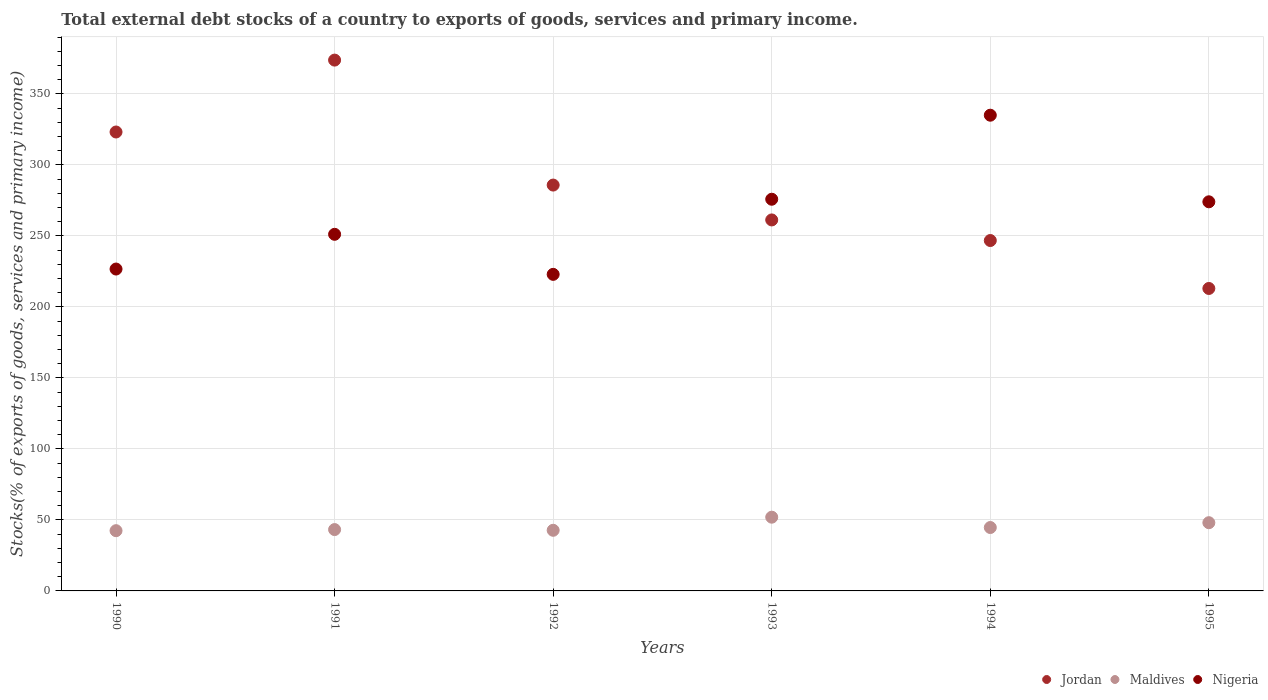How many different coloured dotlines are there?
Provide a short and direct response. 3. Is the number of dotlines equal to the number of legend labels?
Give a very brief answer. Yes. What is the total debt stocks in Nigeria in 1995?
Make the answer very short. 274.01. Across all years, what is the maximum total debt stocks in Jordan?
Give a very brief answer. 373.79. Across all years, what is the minimum total debt stocks in Nigeria?
Provide a succinct answer. 222.92. In which year was the total debt stocks in Maldives minimum?
Your answer should be very brief. 1990. What is the total total debt stocks in Nigeria in the graph?
Your answer should be compact. 1585.52. What is the difference between the total debt stocks in Nigeria in 1994 and that in 1995?
Provide a succinct answer. 60.98. What is the difference between the total debt stocks in Nigeria in 1994 and the total debt stocks in Jordan in 1990?
Give a very brief answer. 11.82. What is the average total debt stocks in Jordan per year?
Provide a succinct answer. 283.95. In the year 1991, what is the difference between the total debt stocks in Jordan and total debt stocks in Nigeria?
Provide a short and direct response. 122.67. In how many years, is the total debt stocks in Jordan greater than 120 %?
Provide a short and direct response. 6. What is the ratio of the total debt stocks in Jordan in 1990 to that in 1991?
Your answer should be compact. 0.86. Is the total debt stocks in Nigeria in 1990 less than that in 1992?
Provide a short and direct response. No. What is the difference between the highest and the second highest total debt stocks in Jordan?
Provide a succinct answer. 50.63. What is the difference between the highest and the lowest total debt stocks in Nigeria?
Ensure brevity in your answer.  112.07. Is it the case that in every year, the sum of the total debt stocks in Maldives and total debt stocks in Nigeria  is greater than the total debt stocks in Jordan?
Your answer should be compact. No. Is the total debt stocks in Maldives strictly greater than the total debt stocks in Jordan over the years?
Offer a very short reply. No. How many dotlines are there?
Offer a terse response. 3. How many years are there in the graph?
Give a very brief answer. 6. Are the values on the major ticks of Y-axis written in scientific E-notation?
Make the answer very short. No. Does the graph contain any zero values?
Your answer should be compact. No. Does the graph contain grids?
Provide a succinct answer. Yes. How many legend labels are there?
Offer a terse response. 3. What is the title of the graph?
Make the answer very short. Total external debt stocks of a country to exports of goods, services and primary income. Does "Tunisia" appear as one of the legend labels in the graph?
Your answer should be very brief. No. What is the label or title of the X-axis?
Provide a short and direct response. Years. What is the label or title of the Y-axis?
Your response must be concise. Stocks(% of exports of goods, services and primary income). What is the Stocks(% of exports of goods, services and primary income) of Jordan in 1990?
Ensure brevity in your answer.  323.17. What is the Stocks(% of exports of goods, services and primary income) in Maldives in 1990?
Ensure brevity in your answer.  42.42. What is the Stocks(% of exports of goods, services and primary income) of Nigeria in 1990?
Offer a terse response. 226.66. What is the Stocks(% of exports of goods, services and primary income) in Jordan in 1991?
Your answer should be compact. 373.79. What is the Stocks(% of exports of goods, services and primary income) in Maldives in 1991?
Offer a very short reply. 43.2. What is the Stocks(% of exports of goods, services and primary income) of Nigeria in 1991?
Make the answer very short. 251.12. What is the Stocks(% of exports of goods, services and primary income) of Jordan in 1992?
Your response must be concise. 285.8. What is the Stocks(% of exports of goods, services and primary income) of Maldives in 1992?
Provide a short and direct response. 42.7. What is the Stocks(% of exports of goods, services and primary income) of Nigeria in 1992?
Your answer should be very brief. 222.92. What is the Stocks(% of exports of goods, services and primary income) of Jordan in 1993?
Provide a succinct answer. 261.25. What is the Stocks(% of exports of goods, services and primary income) in Maldives in 1993?
Your answer should be compact. 51.92. What is the Stocks(% of exports of goods, services and primary income) in Nigeria in 1993?
Make the answer very short. 275.82. What is the Stocks(% of exports of goods, services and primary income) in Jordan in 1994?
Provide a succinct answer. 246.74. What is the Stocks(% of exports of goods, services and primary income) in Maldives in 1994?
Keep it short and to the point. 44.65. What is the Stocks(% of exports of goods, services and primary income) of Nigeria in 1994?
Your response must be concise. 334.99. What is the Stocks(% of exports of goods, services and primary income) in Jordan in 1995?
Keep it short and to the point. 212.98. What is the Stocks(% of exports of goods, services and primary income) of Maldives in 1995?
Your answer should be very brief. 48.04. What is the Stocks(% of exports of goods, services and primary income) in Nigeria in 1995?
Your response must be concise. 274.01. Across all years, what is the maximum Stocks(% of exports of goods, services and primary income) of Jordan?
Give a very brief answer. 373.79. Across all years, what is the maximum Stocks(% of exports of goods, services and primary income) of Maldives?
Give a very brief answer. 51.92. Across all years, what is the maximum Stocks(% of exports of goods, services and primary income) of Nigeria?
Your answer should be very brief. 334.99. Across all years, what is the minimum Stocks(% of exports of goods, services and primary income) of Jordan?
Your answer should be compact. 212.98. Across all years, what is the minimum Stocks(% of exports of goods, services and primary income) of Maldives?
Offer a very short reply. 42.42. Across all years, what is the minimum Stocks(% of exports of goods, services and primary income) in Nigeria?
Give a very brief answer. 222.92. What is the total Stocks(% of exports of goods, services and primary income) in Jordan in the graph?
Provide a succinct answer. 1703.72. What is the total Stocks(% of exports of goods, services and primary income) of Maldives in the graph?
Keep it short and to the point. 272.93. What is the total Stocks(% of exports of goods, services and primary income) of Nigeria in the graph?
Provide a succinct answer. 1585.52. What is the difference between the Stocks(% of exports of goods, services and primary income) in Jordan in 1990 and that in 1991?
Offer a very short reply. -50.63. What is the difference between the Stocks(% of exports of goods, services and primary income) of Maldives in 1990 and that in 1991?
Provide a short and direct response. -0.78. What is the difference between the Stocks(% of exports of goods, services and primary income) of Nigeria in 1990 and that in 1991?
Your answer should be compact. -24.46. What is the difference between the Stocks(% of exports of goods, services and primary income) of Jordan in 1990 and that in 1992?
Offer a very short reply. 37.37. What is the difference between the Stocks(% of exports of goods, services and primary income) in Maldives in 1990 and that in 1992?
Give a very brief answer. -0.28. What is the difference between the Stocks(% of exports of goods, services and primary income) in Nigeria in 1990 and that in 1992?
Make the answer very short. 3.74. What is the difference between the Stocks(% of exports of goods, services and primary income) in Jordan in 1990 and that in 1993?
Your answer should be very brief. 61.92. What is the difference between the Stocks(% of exports of goods, services and primary income) of Maldives in 1990 and that in 1993?
Give a very brief answer. -9.5. What is the difference between the Stocks(% of exports of goods, services and primary income) of Nigeria in 1990 and that in 1993?
Offer a terse response. -49.16. What is the difference between the Stocks(% of exports of goods, services and primary income) of Jordan in 1990 and that in 1994?
Make the answer very short. 76.42. What is the difference between the Stocks(% of exports of goods, services and primary income) of Maldives in 1990 and that in 1994?
Offer a terse response. -2.23. What is the difference between the Stocks(% of exports of goods, services and primary income) of Nigeria in 1990 and that in 1994?
Make the answer very short. -108.33. What is the difference between the Stocks(% of exports of goods, services and primary income) in Jordan in 1990 and that in 1995?
Your response must be concise. 110.18. What is the difference between the Stocks(% of exports of goods, services and primary income) of Maldives in 1990 and that in 1995?
Your response must be concise. -5.62. What is the difference between the Stocks(% of exports of goods, services and primary income) of Nigeria in 1990 and that in 1995?
Provide a short and direct response. -47.35. What is the difference between the Stocks(% of exports of goods, services and primary income) in Jordan in 1991 and that in 1992?
Offer a very short reply. 88. What is the difference between the Stocks(% of exports of goods, services and primary income) in Maldives in 1991 and that in 1992?
Offer a very short reply. 0.5. What is the difference between the Stocks(% of exports of goods, services and primary income) of Nigeria in 1991 and that in 1992?
Provide a short and direct response. 28.2. What is the difference between the Stocks(% of exports of goods, services and primary income) in Jordan in 1991 and that in 1993?
Your answer should be compact. 112.55. What is the difference between the Stocks(% of exports of goods, services and primary income) in Maldives in 1991 and that in 1993?
Your answer should be very brief. -8.73. What is the difference between the Stocks(% of exports of goods, services and primary income) of Nigeria in 1991 and that in 1993?
Provide a succinct answer. -24.7. What is the difference between the Stocks(% of exports of goods, services and primary income) of Jordan in 1991 and that in 1994?
Give a very brief answer. 127.05. What is the difference between the Stocks(% of exports of goods, services and primary income) of Maldives in 1991 and that in 1994?
Give a very brief answer. -1.45. What is the difference between the Stocks(% of exports of goods, services and primary income) of Nigeria in 1991 and that in 1994?
Ensure brevity in your answer.  -83.87. What is the difference between the Stocks(% of exports of goods, services and primary income) of Jordan in 1991 and that in 1995?
Ensure brevity in your answer.  160.81. What is the difference between the Stocks(% of exports of goods, services and primary income) of Maldives in 1991 and that in 1995?
Make the answer very short. -4.84. What is the difference between the Stocks(% of exports of goods, services and primary income) in Nigeria in 1991 and that in 1995?
Offer a terse response. -22.89. What is the difference between the Stocks(% of exports of goods, services and primary income) in Jordan in 1992 and that in 1993?
Offer a terse response. 24.55. What is the difference between the Stocks(% of exports of goods, services and primary income) in Maldives in 1992 and that in 1993?
Keep it short and to the point. -9.23. What is the difference between the Stocks(% of exports of goods, services and primary income) in Nigeria in 1992 and that in 1993?
Provide a short and direct response. -52.89. What is the difference between the Stocks(% of exports of goods, services and primary income) in Jordan in 1992 and that in 1994?
Offer a very short reply. 39.05. What is the difference between the Stocks(% of exports of goods, services and primary income) of Maldives in 1992 and that in 1994?
Keep it short and to the point. -1.95. What is the difference between the Stocks(% of exports of goods, services and primary income) of Nigeria in 1992 and that in 1994?
Keep it short and to the point. -112.07. What is the difference between the Stocks(% of exports of goods, services and primary income) of Jordan in 1992 and that in 1995?
Give a very brief answer. 72.81. What is the difference between the Stocks(% of exports of goods, services and primary income) in Maldives in 1992 and that in 1995?
Make the answer very short. -5.35. What is the difference between the Stocks(% of exports of goods, services and primary income) of Nigeria in 1992 and that in 1995?
Keep it short and to the point. -51.09. What is the difference between the Stocks(% of exports of goods, services and primary income) of Jordan in 1993 and that in 1994?
Give a very brief answer. 14.51. What is the difference between the Stocks(% of exports of goods, services and primary income) of Maldives in 1993 and that in 1994?
Your answer should be very brief. 7.27. What is the difference between the Stocks(% of exports of goods, services and primary income) in Nigeria in 1993 and that in 1994?
Your answer should be very brief. -59.18. What is the difference between the Stocks(% of exports of goods, services and primary income) of Jordan in 1993 and that in 1995?
Offer a terse response. 48.27. What is the difference between the Stocks(% of exports of goods, services and primary income) in Maldives in 1993 and that in 1995?
Your response must be concise. 3.88. What is the difference between the Stocks(% of exports of goods, services and primary income) in Nigeria in 1993 and that in 1995?
Your answer should be compact. 1.8. What is the difference between the Stocks(% of exports of goods, services and primary income) of Jordan in 1994 and that in 1995?
Give a very brief answer. 33.76. What is the difference between the Stocks(% of exports of goods, services and primary income) in Maldives in 1994 and that in 1995?
Your answer should be very brief. -3.39. What is the difference between the Stocks(% of exports of goods, services and primary income) in Nigeria in 1994 and that in 1995?
Offer a terse response. 60.98. What is the difference between the Stocks(% of exports of goods, services and primary income) of Jordan in 1990 and the Stocks(% of exports of goods, services and primary income) of Maldives in 1991?
Keep it short and to the point. 279.97. What is the difference between the Stocks(% of exports of goods, services and primary income) of Jordan in 1990 and the Stocks(% of exports of goods, services and primary income) of Nigeria in 1991?
Keep it short and to the point. 72.05. What is the difference between the Stocks(% of exports of goods, services and primary income) of Maldives in 1990 and the Stocks(% of exports of goods, services and primary income) of Nigeria in 1991?
Your answer should be very brief. -208.7. What is the difference between the Stocks(% of exports of goods, services and primary income) in Jordan in 1990 and the Stocks(% of exports of goods, services and primary income) in Maldives in 1992?
Offer a very short reply. 280.47. What is the difference between the Stocks(% of exports of goods, services and primary income) of Jordan in 1990 and the Stocks(% of exports of goods, services and primary income) of Nigeria in 1992?
Provide a short and direct response. 100.24. What is the difference between the Stocks(% of exports of goods, services and primary income) of Maldives in 1990 and the Stocks(% of exports of goods, services and primary income) of Nigeria in 1992?
Make the answer very short. -180.5. What is the difference between the Stocks(% of exports of goods, services and primary income) of Jordan in 1990 and the Stocks(% of exports of goods, services and primary income) of Maldives in 1993?
Your response must be concise. 271.24. What is the difference between the Stocks(% of exports of goods, services and primary income) of Jordan in 1990 and the Stocks(% of exports of goods, services and primary income) of Nigeria in 1993?
Make the answer very short. 47.35. What is the difference between the Stocks(% of exports of goods, services and primary income) in Maldives in 1990 and the Stocks(% of exports of goods, services and primary income) in Nigeria in 1993?
Provide a succinct answer. -233.4. What is the difference between the Stocks(% of exports of goods, services and primary income) in Jordan in 1990 and the Stocks(% of exports of goods, services and primary income) in Maldives in 1994?
Your answer should be very brief. 278.52. What is the difference between the Stocks(% of exports of goods, services and primary income) of Jordan in 1990 and the Stocks(% of exports of goods, services and primary income) of Nigeria in 1994?
Ensure brevity in your answer.  -11.82. What is the difference between the Stocks(% of exports of goods, services and primary income) of Maldives in 1990 and the Stocks(% of exports of goods, services and primary income) of Nigeria in 1994?
Provide a short and direct response. -292.57. What is the difference between the Stocks(% of exports of goods, services and primary income) of Jordan in 1990 and the Stocks(% of exports of goods, services and primary income) of Maldives in 1995?
Provide a succinct answer. 275.12. What is the difference between the Stocks(% of exports of goods, services and primary income) in Jordan in 1990 and the Stocks(% of exports of goods, services and primary income) in Nigeria in 1995?
Offer a terse response. 49.15. What is the difference between the Stocks(% of exports of goods, services and primary income) in Maldives in 1990 and the Stocks(% of exports of goods, services and primary income) in Nigeria in 1995?
Your answer should be very brief. -231.59. What is the difference between the Stocks(% of exports of goods, services and primary income) of Jordan in 1991 and the Stocks(% of exports of goods, services and primary income) of Maldives in 1992?
Provide a succinct answer. 331.1. What is the difference between the Stocks(% of exports of goods, services and primary income) in Jordan in 1991 and the Stocks(% of exports of goods, services and primary income) in Nigeria in 1992?
Provide a short and direct response. 150.87. What is the difference between the Stocks(% of exports of goods, services and primary income) in Maldives in 1991 and the Stocks(% of exports of goods, services and primary income) in Nigeria in 1992?
Your answer should be very brief. -179.72. What is the difference between the Stocks(% of exports of goods, services and primary income) in Jordan in 1991 and the Stocks(% of exports of goods, services and primary income) in Maldives in 1993?
Keep it short and to the point. 321.87. What is the difference between the Stocks(% of exports of goods, services and primary income) in Jordan in 1991 and the Stocks(% of exports of goods, services and primary income) in Nigeria in 1993?
Offer a terse response. 97.98. What is the difference between the Stocks(% of exports of goods, services and primary income) of Maldives in 1991 and the Stocks(% of exports of goods, services and primary income) of Nigeria in 1993?
Provide a short and direct response. -232.62. What is the difference between the Stocks(% of exports of goods, services and primary income) of Jordan in 1991 and the Stocks(% of exports of goods, services and primary income) of Maldives in 1994?
Keep it short and to the point. 329.14. What is the difference between the Stocks(% of exports of goods, services and primary income) in Jordan in 1991 and the Stocks(% of exports of goods, services and primary income) in Nigeria in 1994?
Provide a short and direct response. 38.8. What is the difference between the Stocks(% of exports of goods, services and primary income) of Maldives in 1991 and the Stocks(% of exports of goods, services and primary income) of Nigeria in 1994?
Make the answer very short. -291.79. What is the difference between the Stocks(% of exports of goods, services and primary income) in Jordan in 1991 and the Stocks(% of exports of goods, services and primary income) in Maldives in 1995?
Your answer should be very brief. 325.75. What is the difference between the Stocks(% of exports of goods, services and primary income) of Jordan in 1991 and the Stocks(% of exports of goods, services and primary income) of Nigeria in 1995?
Provide a succinct answer. 99.78. What is the difference between the Stocks(% of exports of goods, services and primary income) of Maldives in 1991 and the Stocks(% of exports of goods, services and primary income) of Nigeria in 1995?
Ensure brevity in your answer.  -230.81. What is the difference between the Stocks(% of exports of goods, services and primary income) in Jordan in 1992 and the Stocks(% of exports of goods, services and primary income) in Maldives in 1993?
Provide a short and direct response. 233.87. What is the difference between the Stocks(% of exports of goods, services and primary income) in Jordan in 1992 and the Stocks(% of exports of goods, services and primary income) in Nigeria in 1993?
Your answer should be compact. 9.98. What is the difference between the Stocks(% of exports of goods, services and primary income) of Maldives in 1992 and the Stocks(% of exports of goods, services and primary income) of Nigeria in 1993?
Your answer should be very brief. -233.12. What is the difference between the Stocks(% of exports of goods, services and primary income) in Jordan in 1992 and the Stocks(% of exports of goods, services and primary income) in Maldives in 1994?
Provide a succinct answer. 241.15. What is the difference between the Stocks(% of exports of goods, services and primary income) of Jordan in 1992 and the Stocks(% of exports of goods, services and primary income) of Nigeria in 1994?
Offer a very short reply. -49.19. What is the difference between the Stocks(% of exports of goods, services and primary income) of Maldives in 1992 and the Stocks(% of exports of goods, services and primary income) of Nigeria in 1994?
Give a very brief answer. -292.29. What is the difference between the Stocks(% of exports of goods, services and primary income) in Jordan in 1992 and the Stocks(% of exports of goods, services and primary income) in Maldives in 1995?
Make the answer very short. 237.75. What is the difference between the Stocks(% of exports of goods, services and primary income) of Jordan in 1992 and the Stocks(% of exports of goods, services and primary income) of Nigeria in 1995?
Provide a short and direct response. 11.79. What is the difference between the Stocks(% of exports of goods, services and primary income) in Maldives in 1992 and the Stocks(% of exports of goods, services and primary income) in Nigeria in 1995?
Offer a very short reply. -231.31. What is the difference between the Stocks(% of exports of goods, services and primary income) in Jordan in 1993 and the Stocks(% of exports of goods, services and primary income) in Maldives in 1994?
Give a very brief answer. 216.6. What is the difference between the Stocks(% of exports of goods, services and primary income) in Jordan in 1993 and the Stocks(% of exports of goods, services and primary income) in Nigeria in 1994?
Offer a very short reply. -73.74. What is the difference between the Stocks(% of exports of goods, services and primary income) of Maldives in 1993 and the Stocks(% of exports of goods, services and primary income) of Nigeria in 1994?
Provide a short and direct response. -283.07. What is the difference between the Stocks(% of exports of goods, services and primary income) in Jordan in 1993 and the Stocks(% of exports of goods, services and primary income) in Maldives in 1995?
Make the answer very short. 213.2. What is the difference between the Stocks(% of exports of goods, services and primary income) in Jordan in 1993 and the Stocks(% of exports of goods, services and primary income) in Nigeria in 1995?
Provide a succinct answer. -12.76. What is the difference between the Stocks(% of exports of goods, services and primary income) in Maldives in 1993 and the Stocks(% of exports of goods, services and primary income) in Nigeria in 1995?
Ensure brevity in your answer.  -222.09. What is the difference between the Stocks(% of exports of goods, services and primary income) of Jordan in 1994 and the Stocks(% of exports of goods, services and primary income) of Maldives in 1995?
Provide a short and direct response. 198.7. What is the difference between the Stocks(% of exports of goods, services and primary income) of Jordan in 1994 and the Stocks(% of exports of goods, services and primary income) of Nigeria in 1995?
Provide a succinct answer. -27.27. What is the difference between the Stocks(% of exports of goods, services and primary income) in Maldives in 1994 and the Stocks(% of exports of goods, services and primary income) in Nigeria in 1995?
Your answer should be very brief. -229.36. What is the average Stocks(% of exports of goods, services and primary income) in Jordan per year?
Provide a short and direct response. 283.95. What is the average Stocks(% of exports of goods, services and primary income) in Maldives per year?
Keep it short and to the point. 45.49. What is the average Stocks(% of exports of goods, services and primary income) in Nigeria per year?
Provide a succinct answer. 264.25. In the year 1990, what is the difference between the Stocks(% of exports of goods, services and primary income) in Jordan and Stocks(% of exports of goods, services and primary income) in Maldives?
Your response must be concise. 280.75. In the year 1990, what is the difference between the Stocks(% of exports of goods, services and primary income) of Jordan and Stocks(% of exports of goods, services and primary income) of Nigeria?
Provide a short and direct response. 96.51. In the year 1990, what is the difference between the Stocks(% of exports of goods, services and primary income) in Maldives and Stocks(% of exports of goods, services and primary income) in Nigeria?
Ensure brevity in your answer.  -184.24. In the year 1991, what is the difference between the Stocks(% of exports of goods, services and primary income) of Jordan and Stocks(% of exports of goods, services and primary income) of Maldives?
Your response must be concise. 330.59. In the year 1991, what is the difference between the Stocks(% of exports of goods, services and primary income) of Jordan and Stocks(% of exports of goods, services and primary income) of Nigeria?
Make the answer very short. 122.67. In the year 1991, what is the difference between the Stocks(% of exports of goods, services and primary income) in Maldives and Stocks(% of exports of goods, services and primary income) in Nigeria?
Provide a succinct answer. -207.92. In the year 1992, what is the difference between the Stocks(% of exports of goods, services and primary income) in Jordan and Stocks(% of exports of goods, services and primary income) in Maldives?
Offer a terse response. 243.1. In the year 1992, what is the difference between the Stocks(% of exports of goods, services and primary income) in Jordan and Stocks(% of exports of goods, services and primary income) in Nigeria?
Make the answer very short. 62.87. In the year 1992, what is the difference between the Stocks(% of exports of goods, services and primary income) of Maldives and Stocks(% of exports of goods, services and primary income) of Nigeria?
Give a very brief answer. -180.22. In the year 1993, what is the difference between the Stocks(% of exports of goods, services and primary income) in Jordan and Stocks(% of exports of goods, services and primary income) in Maldives?
Your answer should be very brief. 209.32. In the year 1993, what is the difference between the Stocks(% of exports of goods, services and primary income) of Jordan and Stocks(% of exports of goods, services and primary income) of Nigeria?
Provide a succinct answer. -14.57. In the year 1993, what is the difference between the Stocks(% of exports of goods, services and primary income) of Maldives and Stocks(% of exports of goods, services and primary income) of Nigeria?
Keep it short and to the point. -223.89. In the year 1994, what is the difference between the Stocks(% of exports of goods, services and primary income) of Jordan and Stocks(% of exports of goods, services and primary income) of Maldives?
Make the answer very short. 202.09. In the year 1994, what is the difference between the Stocks(% of exports of goods, services and primary income) of Jordan and Stocks(% of exports of goods, services and primary income) of Nigeria?
Offer a very short reply. -88.25. In the year 1994, what is the difference between the Stocks(% of exports of goods, services and primary income) of Maldives and Stocks(% of exports of goods, services and primary income) of Nigeria?
Keep it short and to the point. -290.34. In the year 1995, what is the difference between the Stocks(% of exports of goods, services and primary income) of Jordan and Stocks(% of exports of goods, services and primary income) of Maldives?
Give a very brief answer. 164.94. In the year 1995, what is the difference between the Stocks(% of exports of goods, services and primary income) of Jordan and Stocks(% of exports of goods, services and primary income) of Nigeria?
Your response must be concise. -61.03. In the year 1995, what is the difference between the Stocks(% of exports of goods, services and primary income) of Maldives and Stocks(% of exports of goods, services and primary income) of Nigeria?
Keep it short and to the point. -225.97. What is the ratio of the Stocks(% of exports of goods, services and primary income) in Jordan in 1990 to that in 1991?
Offer a very short reply. 0.86. What is the ratio of the Stocks(% of exports of goods, services and primary income) of Nigeria in 1990 to that in 1991?
Give a very brief answer. 0.9. What is the ratio of the Stocks(% of exports of goods, services and primary income) in Jordan in 1990 to that in 1992?
Provide a succinct answer. 1.13. What is the ratio of the Stocks(% of exports of goods, services and primary income) of Maldives in 1990 to that in 1992?
Make the answer very short. 0.99. What is the ratio of the Stocks(% of exports of goods, services and primary income) of Nigeria in 1990 to that in 1992?
Your answer should be compact. 1.02. What is the ratio of the Stocks(% of exports of goods, services and primary income) in Jordan in 1990 to that in 1993?
Provide a succinct answer. 1.24. What is the ratio of the Stocks(% of exports of goods, services and primary income) in Maldives in 1990 to that in 1993?
Give a very brief answer. 0.82. What is the ratio of the Stocks(% of exports of goods, services and primary income) in Nigeria in 1990 to that in 1993?
Your response must be concise. 0.82. What is the ratio of the Stocks(% of exports of goods, services and primary income) of Jordan in 1990 to that in 1994?
Offer a very short reply. 1.31. What is the ratio of the Stocks(% of exports of goods, services and primary income) of Nigeria in 1990 to that in 1994?
Provide a short and direct response. 0.68. What is the ratio of the Stocks(% of exports of goods, services and primary income) in Jordan in 1990 to that in 1995?
Your answer should be compact. 1.52. What is the ratio of the Stocks(% of exports of goods, services and primary income) in Maldives in 1990 to that in 1995?
Your answer should be compact. 0.88. What is the ratio of the Stocks(% of exports of goods, services and primary income) of Nigeria in 1990 to that in 1995?
Keep it short and to the point. 0.83. What is the ratio of the Stocks(% of exports of goods, services and primary income) in Jordan in 1991 to that in 1992?
Your response must be concise. 1.31. What is the ratio of the Stocks(% of exports of goods, services and primary income) of Maldives in 1991 to that in 1992?
Provide a short and direct response. 1.01. What is the ratio of the Stocks(% of exports of goods, services and primary income) in Nigeria in 1991 to that in 1992?
Provide a succinct answer. 1.13. What is the ratio of the Stocks(% of exports of goods, services and primary income) of Jordan in 1991 to that in 1993?
Give a very brief answer. 1.43. What is the ratio of the Stocks(% of exports of goods, services and primary income) of Maldives in 1991 to that in 1993?
Ensure brevity in your answer.  0.83. What is the ratio of the Stocks(% of exports of goods, services and primary income) in Nigeria in 1991 to that in 1993?
Offer a very short reply. 0.91. What is the ratio of the Stocks(% of exports of goods, services and primary income) of Jordan in 1991 to that in 1994?
Keep it short and to the point. 1.51. What is the ratio of the Stocks(% of exports of goods, services and primary income) of Maldives in 1991 to that in 1994?
Ensure brevity in your answer.  0.97. What is the ratio of the Stocks(% of exports of goods, services and primary income) in Nigeria in 1991 to that in 1994?
Your response must be concise. 0.75. What is the ratio of the Stocks(% of exports of goods, services and primary income) in Jordan in 1991 to that in 1995?
Provide a succinct answer. 1.75. What is the ratio of the Stocks(% of exports of goods, services and primary income) of Maldives in 1991 to that in 1995?
Keep it short and to the point. 0.9. What is the ratio of the Stocks(% of exports of goods, services and primary income) in Nigeria in 1991 to that in 1995?
Ensure brevity in your answer.  0.92. What is the ratio of the Stocks(% of exports of goods, services and primary income) in Jordan in 1992 to that in 1993?
Your response must be concise. 1.09. What is the ratio of the Stocks(% of exports of goods, services and primary income) in Maldives in 1992 to that in 1993?
Provide a short and direct response. 0.82. What is the ratio of the Stocks(% of exports of goods, services and primary income) in Nigeria in 1992 to that in 1993?
Offer a terse response. 0.81. What is the ratio of the Stocks(% of exports of goods, services and primary income) in Jordan in 1992 to that in 1994?
Provide a short and direct response. 1.16. What is the ratio of the Stocks(% of exports of goods, services and primary income) of Maldives in 1992 to that in 1994?
Give a very brief answer. 0.96. What is the ratio of the Stocks(% of exports of goods, services and primary income) in Nigeria in 1992 to that in 1994?
Your answer should be very brief. 0.67. What is the ratio of the Stocks(% of exports of goods, services and primary income) in Jordan in 1992 to that in 1995?
Your answer should be very brief. 1.34. What is the ratio of the Stocks(% of exports of goods, services and primary income) in Maldives in 1992 to that in 1995?
Give a very brief answer. 0.89. What is the ratio of the Stocks(% of exports of goods, services and primary income) of Nigeria in 1992 to that in 1995?
Ensure brevity in your answer.  0.81. What is the ratio of the Stocks(% of exports of goods, services and primary income) of Jordan in 1993 to that in 1994?
Make the answer very short. 1.06. What is the ratio of the Stocks(% of exports of goods, services and primary income) in Maldives in 1993 to that in 1994?
Provide a short and direct response. 1.16. What is the ratio of the Stocks(% of exports of goods, services and primary income) in Nigeria in 1993 to that in 1994?
Keep it short and to the point. 0.82. What is the ratio of the Stocks(% of exports of goods, services and primary income) of Jordan in 1993 to that in 1995?
Make the answer very short. 1.23. What is the ratio of the Stocks(% of exports of goods, services and primary income) in Maldives in 1993 to that in 1995?
Offer a very short reply. 1.08. What is the ratio of the Stocks(% of exports of goods, services and primary income) of Nigeria in 1993 to that in 1995?
Your response must be concise. 1.01. What is the ratio of the Stocks(% of exports of goods, services and primary income) of Jordan in 1994 to that in 1995?
Make the answer very short. 1.16. What is the ratio of the Stocks(% of exports of goods, services and primary income) of Maldives in 1994 to that in 1995?
Ensure brevity in your answer.  0.93. What is the ratio of the Stocks(% of exports of goods, services and primary income) of Nigeria in 1994 to that in 1995?
Give a very brief answer. 1.22. What is the difference between the highest and the second highest Stocks(% of exports of goods, services and primary income) of Jordan?
Your answer should be very brief. 50.63. What is the difference between the highest and the second highest Stocks(% of exports of goods, services and primary income) in Maldives?
Keep it short and to the point. 3.88. What is the difference between the highest and the second highest Stocks(% of exports of goods, services and primary income) in Nigeria?
Provide a succinct answer. 59.18. What is the difference between the highest and the lowest Stocks(% of exports of goods, services and primary income) of Jordan?
Give a very brief answer. 160.81. What is the difference between the highest and the lowest Stocks(% of exports of goods, services and primary income) of Maldives?
Your response must be concise. 9.5. What is the difference between the highest and the lowest Stocks(% of exports of goods, services and primary income) in Nigeria?
Ensure brevity in your answer.  112.07. 